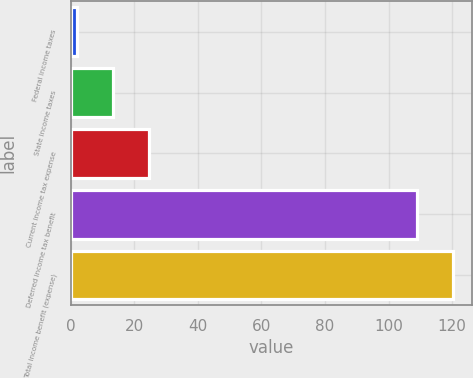<chart> <loc_0><loc_0><loc_500><loc_500><bar_chart><fcel>Federal income taxes<fcel>State income taxes<fcel>Current income tax expense<fcel>Deferred income tax benefit<fcel>Total income benefit (expense)<nl><fcel>2<fcel>13.3<fcel>24.6<fcel>109<fcel>120.3<nl></chart> 